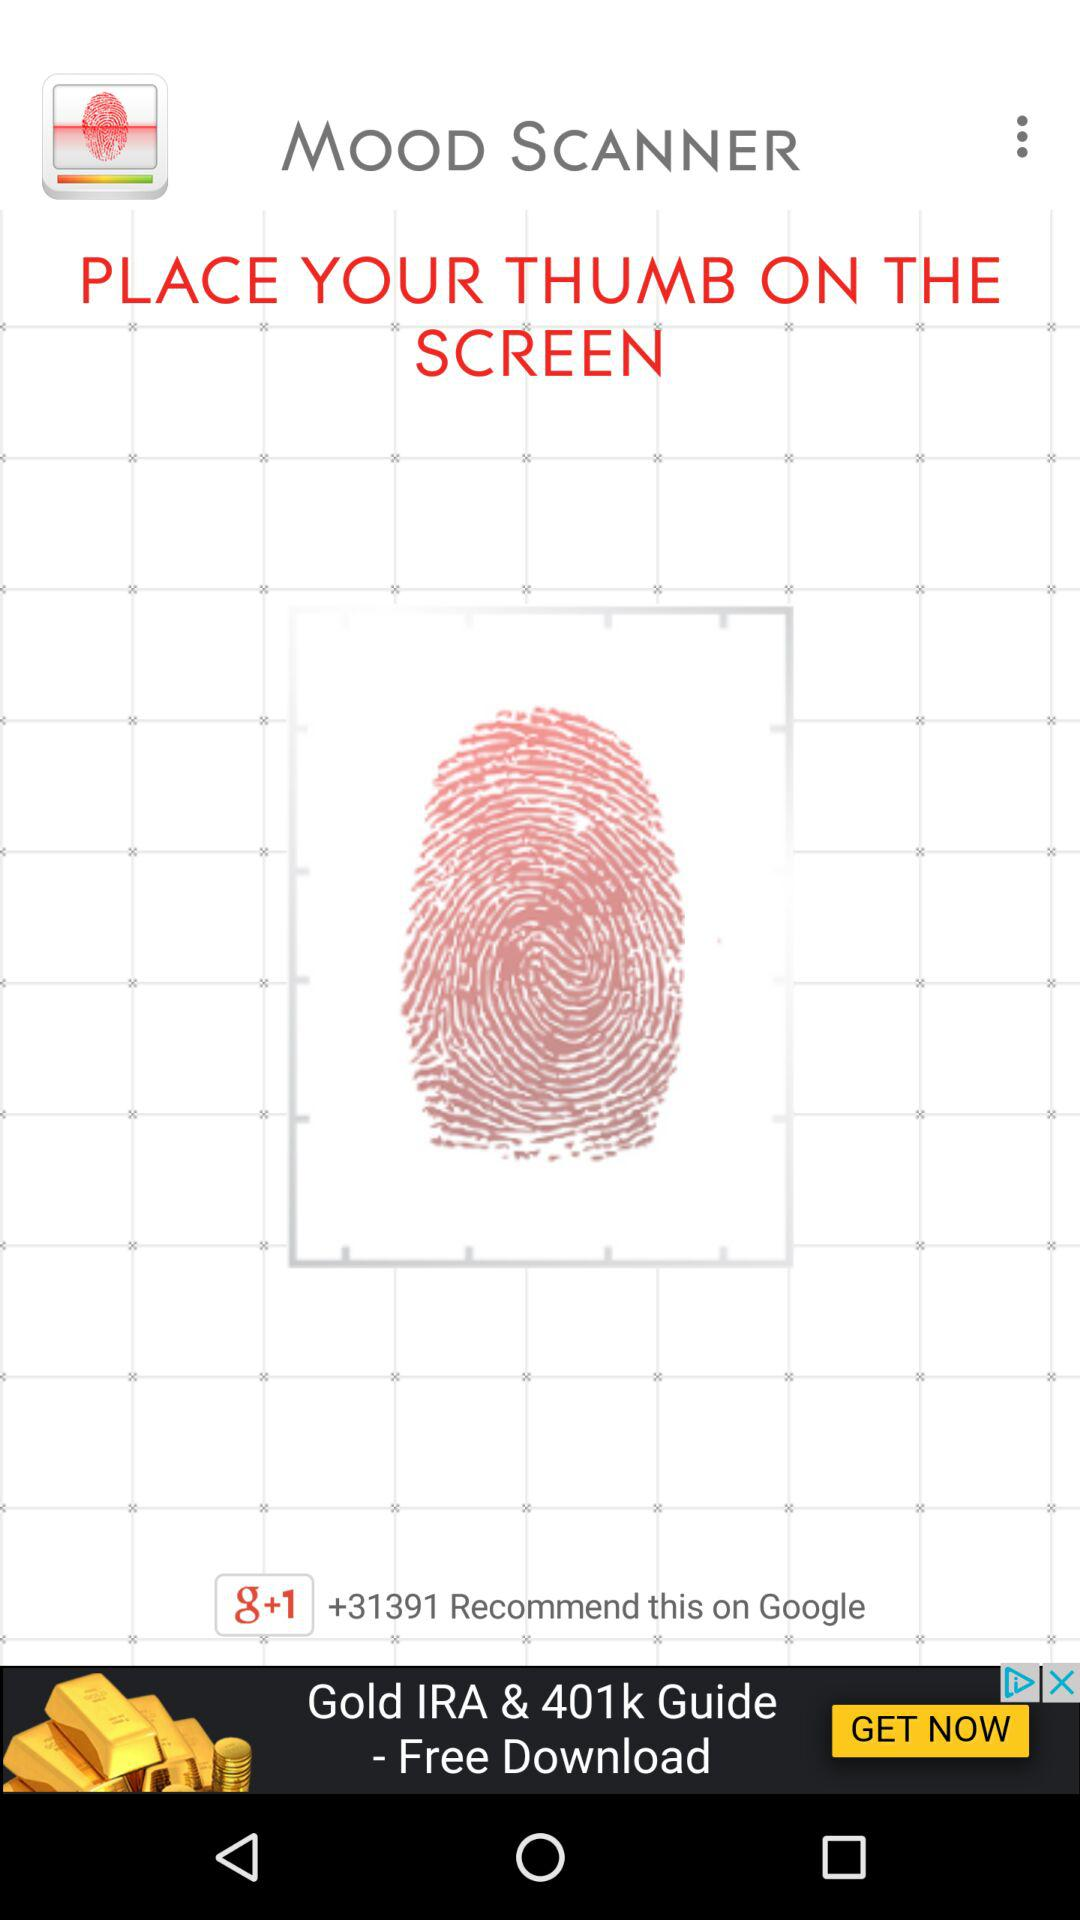What is the application name? The application name is "MOOD SCANNER". 